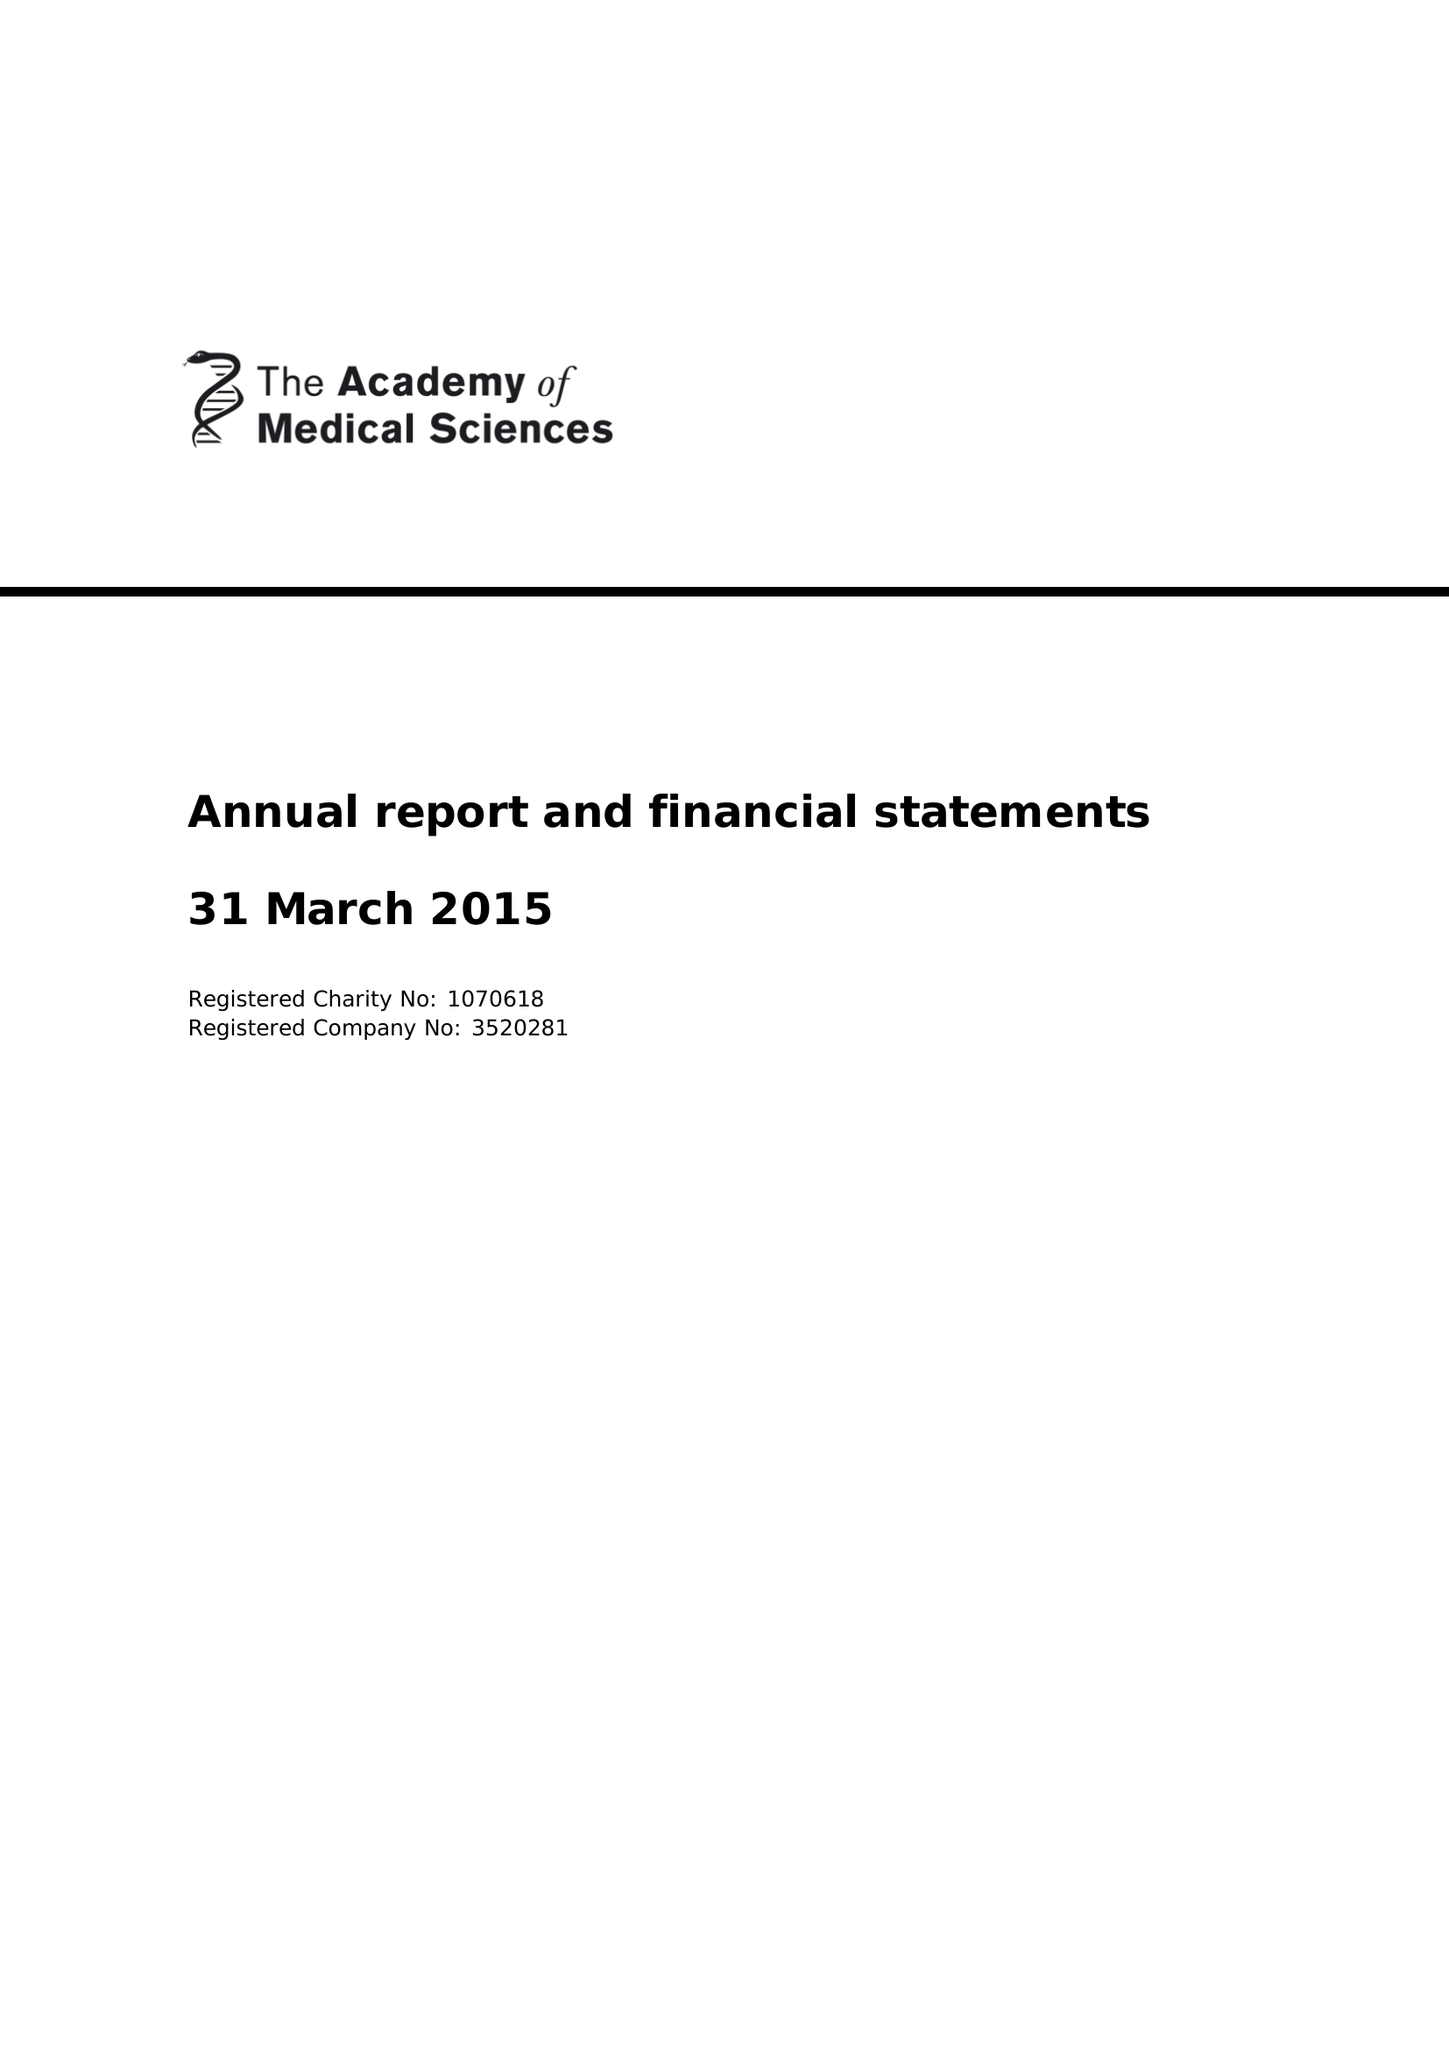What is the value for the charity_number?
Answer the question using a single word or phrase. 1070618 